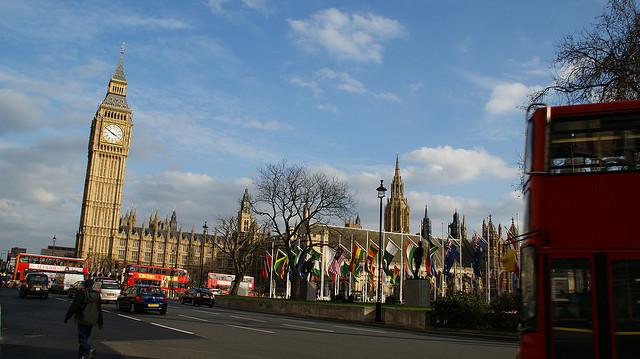What time is on the clock?
Quick response, please. 4:50. Is this picture taken in the daytime?
Short answer required. Yes. What time of day is it?
Concise answer only. Daytime. How many double-decker buses do you see?
Quick response, please. 3. Is there a man walking on the street?
Give a very brief answer. Yes. What vehicle is shown?
Give a very brief answer. Car. What is the green machinery?
Write a very short answer. Car. Is it getting dark?
Quick response, please. No. What color are the clouds?
Quick response, please. White. 